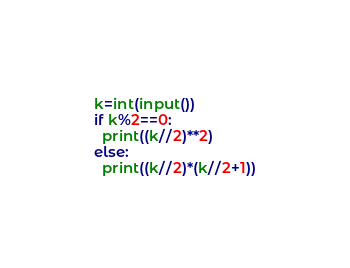Convert code to text. <code><loc_0><loc_0><loc_500><loc_500><_Python_>k=int(input())
if k%2==0:
  print((k//2)**2)
else:
  print((k//2)*(k//2+1))</code> 